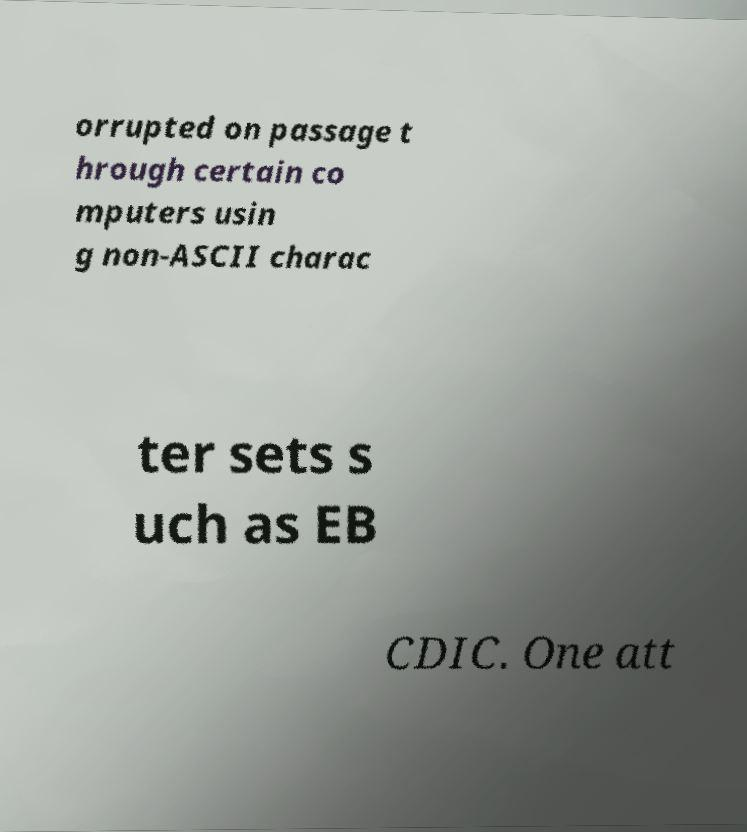What messages or text are displayed in this image? I need them in a readable, typed format. orrupted on passage t hrough certain co mputers usin g non-ASCII charac ter sets s uch as EB CDIC. One att 